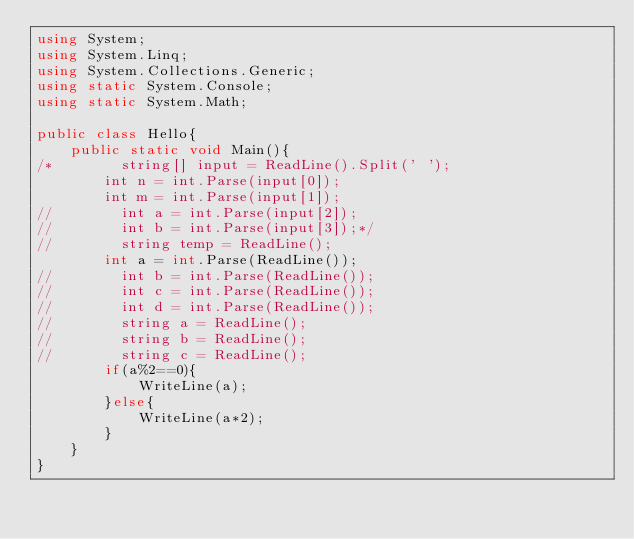Convert code to text. <code><loc_0><loc_0><loc_500><loc_500><_C#_>using System;
using System.Linq;
using System.Collections.Generic;
using static System.Console;
using static System.Math;
 
public class Hello{
    public static void Main(){
/*        string[] input = ReadLine().Split(' ');
        int n = int.Parse(input[0]);
        int m = int.Parse(input[1]);
//        int a = int.Parse(input[2]);
//        int b = int.Parse(input[3]);*/
//        string temp = ReadLine();
        int a = int.Parse(ReadLine());
//        int b = int.Parse(ReadLine());
//        int c = int.Parse(ReadLine());
//        int d = int.Parse(ReadLine());
//        string a = ReadLine();
//        string b = ReadLine();
//        string c = ReadLine();
        if(a%2==0){
            WriteLine(a);
        }else{
            WriteLine(a*2);
        }
    }
}</code> 